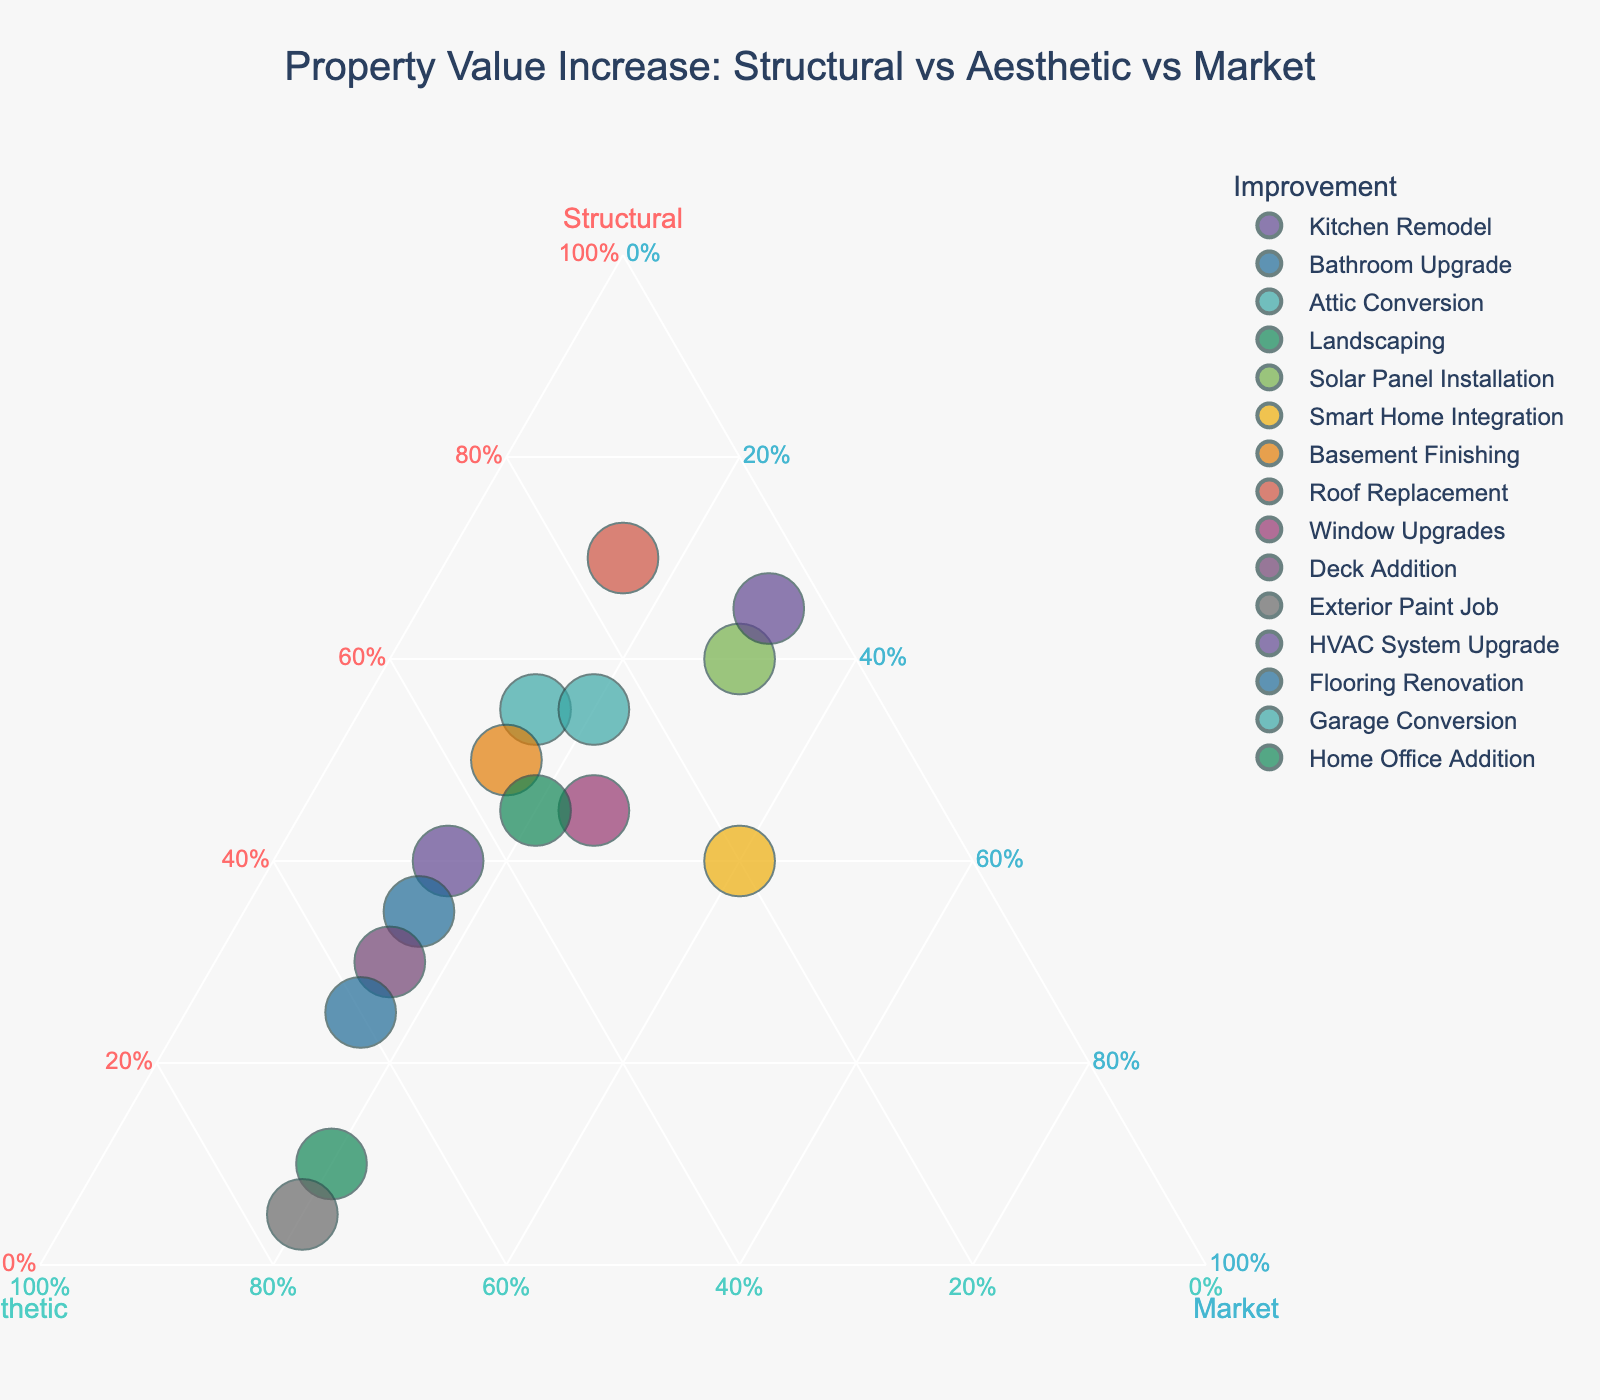What is the title of the ternary plot? The title is typically displayed at the top of the figure and summarizes the content of the plot.
Answer: Property Value Increase: Structural vs Aesthetic vs Market How many improvements are plotted on the ternary plot? You count the number of unique points or names listed in the legend. The number corresponds to the improvement projects.
Answer: 15 Which improvement has the highest percentage attributed to structural enhancements? Locate the point closest to the 'Structural' axis of the ternary plot. Higher values on this axis indicate a higher proportion of structural enhancements.
Answer: Roof Replacement (70%) What is the percentage breakdown of value increase for the Exterior Paint Job improvement? Hover over or locate the Exterior Paint Job point on the plot. The hover or label should provide the exact percentages for structural, aesthetic, and market.
Answer: Structural: 5%, Aesthetic: 75%, Market: 20% Which improvement has the lowest percentage attributed to the market trend? Locate the points closer to the 'Market' axis origin. Hover over or check the data above this axis to find the improvement with the lowest value.
Answer: HVAC System Upgrade (5%) Compare the percentage contribution of aesthetic enhancements between Kitchen Remodel and Deck Addition. Locate each point on the ternary plot. Compare their positions along the 'Aesthetic' axis or hover over each point to read the aesthetic percentages.
Answer: Kitchen Remodel: 45%, Deck Addition: 55% Identify the improvement with equal contribution percentages for structural and aesthetic enhancements. Locate points that are equidistant along the 'Structural' and 'Aesthetic' axes. Hover over these points to confirm their values.
Answer: Smart Home Integration (40% Structural, 20% Aesthetic, 40% Market) Which improvements have a market contribution of exactly 30%? Locate and verify points that align with the 'Market' contribution line at 30% by hovering over or comparing positions on the plot.
Answer: Solar Panel Installation, HVAC System Upgrade What is the average percentage contribution of structural enhancements across all improvements? Sum the structural percentages from all improvements and divide by the number of improvements. (40+35+55+10+60+40+50+70+45+30+5+65+25+55+45)/15 = 45
Answer: 45% What improvement has the highest combined value of structural and market contributions? Add structural and market percentages for each improvement. Identify the improvement with the highest combined value. Detailed calculations involve: Kitchen Remodel (40+15), Bathroom Upgrade (35+15), etc.
Answer: HVAC System Upgrade (65% Structural + 30% Market = 95%) 